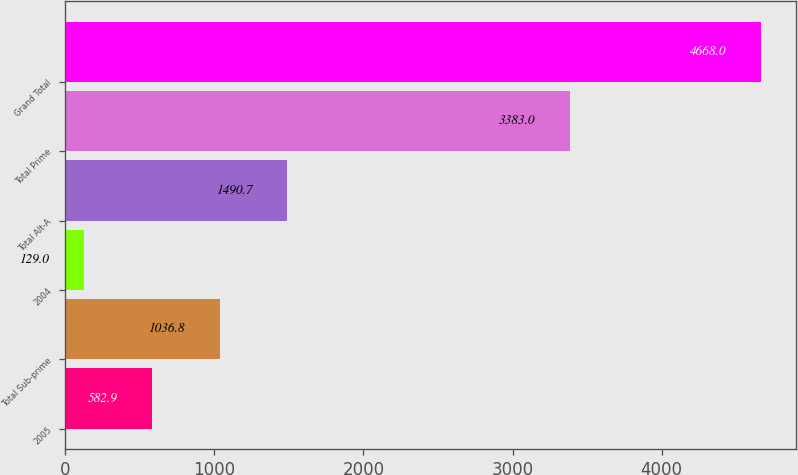<chart> <loc_0><loc_0><loc_500><loc_500><bar_chart><fcel>2005<fcel>Total Sub-prime<fcel>2004<fcel>Total Alt-A<fcel>Total Prime<fcel>Grand Total<nl><fcel>582.9<fcel>1036.8<fcel>129<fcel>1490.7<fcel>3383<fcel>4668<nl></chart> 